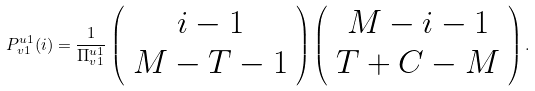Convert formula to latex. <formula><loc_0><loc_0><loc_500><loc_500>P _ { v 1 } ^ { u 1 } ( i ) = \frac { 1 } { \Pi _ { v 1 } ^ { u 1 } } \left ( \begin{array} { c } i - 1 \\ M - T - 1 \end{array} \right ) \left ( \begin{array} { c } M - i - 1 \\ T + C - M \end{array} \right ) .</formula> 